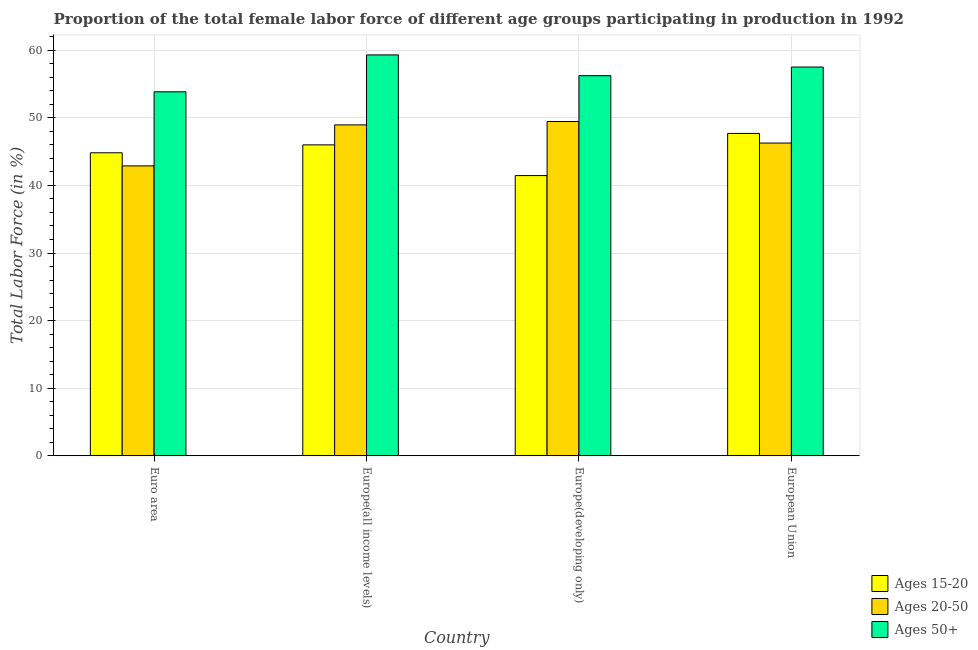How many different coloured bars are there?
Your response must be concise. 3. Are the number of bars per tick equal to the number of legend labels?
Offer a terse response. Yes. Are the number of bars on each tick of the X-axis equal?
Offer a very short reply. Yes. What is the label of the 3rd group of bars from the left?
Give a very brief answer. Europe(developing only). In how many cases, is the number of bars for a given country not equal to the number of legend labels?
Provide a succinct answer. 0. What is the percentage of female labor force within the age group 20-50 in Euro area?
Provide a short and direct response. 42.89. Across all countries, what is the maximum percentage of female labor force above age 50?
Provide a short and direct response. 59.32. Across all countries, what is the minimum percentage of female labor force within the age group 20-50?
Provide a short and direct response. 42.89. In which country was the percentage of female labor force within the age group 15-20 maximum?
Give a very brief answer. European Union. In which country was the percentage of female labor force within the age group 20-50 minimum?
Keep it short and to the point. Euro area. What is the total percentage of female labor force above age 50 in the graph?
Your response must be concise. 226.94. What is the difference between the percentage of female labor force within the age group 15-20 in Euro area and that in European Union?
Your answer should be very brief. -2.87. What is the difference between the percentage of female labor force within the age group 20-50 in Euro area and the percentage of female labor force above age 50 in Europe(all income levels)?
Keep it short and to the point. -16.42. What is the average percentage of female labor force within the age group 20-50 per country?
Your answer should be compact. 46.9. What is the difference between the percentage of female labor force above age 50 and percentage of female labor force within the age group 20-50 in Europe(all income levels)?
Your answer should be very brief. 10.35. In how many countries, is the percentage of female labor force above age 50 greater than 48 %?
Ensure brevity in your answer.  4. What is the ratio of the percentage of female labor force within the age group 15-20 in Europe(developing only) to that in European Union?
Ensure brevity in your answer.  0.87. Is the difference between the percentage of female labor force above age 50 in Europe(developing only) and European Union greater than the difference between the percentage of female labor force within the age group 20-50 in Europe(developing only) and European Union?
Provide a short and direct response. No. What is the difference between the highest and the second highest percentage of female labor force within the age group 20-50?
Make the answer very short. 0.5. What is the difference between the highest and the lowest percentage of female labor force within the age group 15-20?
Provide a succinct answer. 6.24. In how many countries, is the percentage of female labor force above age 50 greater than the average percentage of female labor force above age 50 taken over all countries?
Ensure brevity in your answer.  2. What does the 1st bar from the left in European Union represents?
Provide a succinct answer. Ages 15-20. What does the 2nd bar from the right in European Union represents?
Provide a short and direct response. Ages 20-50. Is it the case that in every country, the sum of the percentage of female labor force within the age group 15-20 and percentage of female labor force within the age group 20-50 is greater than the percentage of female labor force above age 50?
Your answer should be very brief. Yes. How many bars are there?
Your answer should be compact. 12. What is the difference between two consecutive major ticks on the Y-axis?
Your response must be concise. 10. Are the values on the major ticks of Y-axis written in scientific E-notation?
Your response must be concise. No. What is the title of the graph?
Give a very brief answer. Proportion of the total female labor force of different age groups participating in production in 1992. Does "Self-employed" appear as one of the legend labels in the graph?
Your answer should be compact. No. What is the label or title of the X-axis?
Provide a succinct answer. Country. What is the label or title of the Y-axis?
Provide a succinct answer. Total Labor Force (in %). What is the Total Labor Force (in %) of Ages 15-20 in Euro area?
Offer a very short reply. 44.83. What is the Total Labor Force (in %) of Ages 20-50 in Euro area?
Offer a terse response. 42.89. What is the Total Labor Force (in %) of Ages 50+ in Euro area?
Your answer should be very brief. 53.86. What is the Total Labor Force (in %) in Ages 15-20 in Europe(all income levels)?
Keep it short and to the point. 46. What is the Total Labor Force (in %) in Ages 20-50 in Europe(all income levels)?
Offer a very short reply. 48.96. What is the Total Labor Force (in %) in Ages 50+ in Europe(all income levels)?
Ensure brevity in your answer.  59.32. What is the Total Labor Force (in %) of Ages 15-20 in Europe(developing only)?
Provide a short and direct response. 41.46. What is the Total Labor Force (in %) in Ages 20-50 in Europe(developing only)?
Your response must be concise. 49.46. What is the Total Labor Force (in %) of Ages 50+ in Europe(developing only)?
Provide a succinct answer. 56.24. What is the Total Labor Force (in %) of Ages 15-20 in European Union?
Your response must be concise. 47.7. What is the Total Labor Force (in %) in Ages 20-50 in European Union?
Your answer should be compact. 46.27. What is the Total Labor Force (in %) in Ages 50+ in European Union?
Offer a very short reply. 57.52. Across all countries, what is the maximum Total Labor Force (in %) of Ages 15-20?
Give a very brief answer. 47.7. Across all countries, what is the maximum Total Labor Force (in %) of Ages 20-50?
Offer a very short reply. 49.46. Across all countries, what is the maximum Total Labor Force (in %) in Ages 50+?
Offer a terse response. 59.32. Across all countries, what is the minimum Total Labor Force (in %) in Ages 15-20?
Your answer should be very brief. 41.46. Across all countries, what is the minimum Total Labor Force (in %) of Ages 20-50?
Your response must be concise. 42.89. Across all countries, what is the minimum Total Labor Force (in %) in Ages 50+?
Offer a terse response. 53.86. What is the total Total Labor Force (in %) in Ages 15-20 in the graph?
Give a very brief answer. 179.99. What is the total Total Labor Force (in %) in Ages 20-50 in the graph?
Offer a terse response. 187.59. What is the total Total Labor Force (in %) in Ages 50+ in the graph?
Keep it short and to the point. 226.94. What is the difference between the Total Labor Force (in %) in Ages 15-20 in Euro area and that in Europe(all income levels)?
Provide a short and direct response. -1.17. What is the difference between the Total Labor Force (in %) of Ages 20-50 in Euro area and that in Europe(all income levels)?
Your answer should be very brief. -6.07. What is the difference between the Total Labor Force (in %) of Ages 50+ in Euro area and that in Europe(all income levels)?
Your answer should be very brief. -5.46. What is the difference between the Total Labor Force (in %) in Ages 15-20 in Euro area and that in Europe(developing only)?
Provide a short and direct response. 3.37. What is the difference between the Total Labor Force (in %) of Ages 20-50 in Euro area and that in Europe(developing only)?
Ensure brevity in your answer.  -6.57. What is the difference between the Total Labor Force (in %) of Ages 50+ in Euro area and that in Europe(developing only)?
Offer a terse response. -2.39. What is the difference between the Total Labor Force (in %) in Ages 15-20 in Euro area and that in European Union?
Give a very brief answer. -2.87. What is the difference between the Total Labor Force (in %) in Ages 20-50 in Euro area and that in European Union?
Keep it short and to the point. -3.38. What is the difference between the Total Labor Force (in %) in Ages 50+ in Euro area and that in European Union?
Offer a terse response. -3.67. What is the difference between the Total Labor Force (in %) of Ages 15-20 in Europe(all income levels) and that in Europe(developing only)?
Give a very brief answer. 4.55. What is the difference between the Total Labor Force (in %) of Ages 20-50 in Europe(all income levels) and that in Europe(developing only)?
Make the answer very short. -0.5. What is the difference between the Total Labor Force (in %) in Ages 50+ in Europe(all income levels) and that in Europe(developing only)?
Your response must be concise. 3.07. What is the difference between the Total Labor Force (in %) of Ages 15-20 in Europe(all income levels) and that in European Union?
Give a very brief answer. -1.69. What is the difference between the Total Labor Force (in %) in Ages 20-50 in Europe(all income levels) and that in European Union?
Offer a very short reply. 2.69. What is the difference between the Total Labor Force (in %) of Ages 50+ in Europe(all income levels) and that in European Union?
Keep it short and to the point. 1.79. What is the difference between the Total Labor Force (in %) of Ages 15-20 in Europe(developing only) and that in European Union?
Offer a very short reply. -6.24. What is the difference between the Total Labor Force (in %) of Ages 20-50 in Europe(developing only) and that in European Union?
Give a very brief answer. 3.19. What is the difference between the Total Labor Force (in %) in Ages 50+ in Europe(developing only) and that in European Union?
Keep it short and to the point. -1.28. What is the difference between the Total Labor Force (in %) of Ages 15-20 in Euro area and the Total Labor Force (in %) of Ages 20-50 in Europe(all income levels)?
Ensure brevity in your answer.  -4.13. What is the difference between the Total Labor Force (in %) of Ages 15-20 in Euro area and the Total Labor Force (in %) of Ages 50+ in Europe(all income levels)?
Your answer should be very brief. -14.48. What is the difference between the Total Labor Force (in %) in Ages 20-50 in Euro area and the Total Labor Force (in %) in Ages 50+ in Europe(all income levels)?
Offer a very short reply. -16.42. What is the difference between the Total Labor Force (in %) of Ages 15-20 in Euro area and the Total Labor Force (in %) of Ages 20-50 in Europe(developing only)?
Provide a short and direct response. -4.63. What is the difference between the Total Labor Force (in %) in Ages 15-20 in Euro area and the Total Labor Force (in %) in Ages 50+ in Europe(developing only)?
Give a very brief answer. -11.41. What is the difference between the Total Labor Force (in %) of Ages 20-50 in Euro area and the Total Labor Force (in %) of Ages 50+ in Europe(developing only)?
Keep it short and to the point. -13.35. What is the difference between the Total Labor Force (in %) in Ages 15-20 in Euro area and the Total Labor Force (in %) in Ages 20-50 in European Union?
Offer a very short reply. -1.44. What is the difference between the Total Labor Force (in %) of Ages 15-20 in Euro area and the Total Labor Force (in %) of Ages 50+ in European Union?
Ensure brevity in your answer.  -12.69. What is the difference between the Total Labor Force (in %) of Ages 20-50 in Euro area and the Total Labor Force (in %) of Ages 50+ in European Union?
Provide a short and direct response. -14.63. What is the difference between the Total Labor Force (in %) of Ages 15-20 in Europe(all income levels) and the Total Labor Force (in %) of Ages 20-50 in Europe(developing only)?
Provide a succinct answer. -3.46. What is the difference between the Total Labor Force (in %) of Ages 15-20 in Europe(all income levels) and the Total Labor Force (in %) of Ages 50+ in Europe(developing only)?
Your answer should be very brief. -10.24. What is the difference between the Total Labor Force (in %) of Ages 20-50 in Europe(all income levels) and the Total Labor Force (in %) of Ages 50+ in Europe(developing only)?
Your answer should be very brief. -7.28. What is the difference between the Total Labor Force (in %) of Ages 15-20 in Europe(all income levels) and the Total Labor Force (in %) of Ages 20-50 in European Union?
Keep it short and to the point. -0.27. What is the difference between the Total Labor Force (in %) of Ages 15-20 in Europe(all income levels) and the Total Labor Force (in %) of Ages 50+ in European Union?
Your answer should be very brief. -11.52. What is the difference between the Total Labor Force (in %) of Ages 20-50 in Europe(all income levels) and the Total Labor Force (in %) of Ages 50+ in European Union?
Provide a short and direct response. -8.56. What is the difference between the Total Labor Force (in %) in Ages 15-20 in Europe(developing only) and the Total Labor Force (in %) in Ages 20-50 in European Union?
Your answer should be compact. -4.81. What is the difference between the Total Labor Force (in %) in Ages 15-20 in Europe(developing only) and the Total Labor Force (in %) in Ages 50+ in European Union?
Your response must be concise. -16.06. What is the difference between the Total Labor Force (in %) in Ages 20-50 in Europe(developing only) and the Total Labor Force (in %) in Ages 50+ in European Union?
Ensure brevity in your answer.  -8.06. What is the average Total Labor Force (in %) of Ages 15-20 per country?
Your answer should be compact. 45. What is the average Total Labor Force (in %) in Ages 20-50 per country?
Your answer should be compact. 46.9. What is the average Total Labor Force (in %) in Ages 50+ per country?
Keep it short and to the point. 56.73. What is the difference between the Total Labor Force (in %) of Ages 15-20 and Total Labor Force (in %) of Ages 20-50 in Euro area?
Your answer should be very brief. 1.94. What is the difference between the Total Labor Force (in %) in Ages 15-20 and Total Labor Force (in %) in Ages 50+ in Euro area?
Make the answer very short. -9.03. What is the difference between the Total Labor Force (in %) of Ages 20-50 and Total Labor Force (in %) of Ages 50+ in Euro area?
Offer a terse response. -10.96. What is the difference between the Total Labor Force (in %) of Ages 15-20 and Total Labor Force (in %) of Ages 20-50 in Europe(all income levels)?
Make the answer very short. -2.96. What is the difference between the Total Labor Force (in %) of Ages 15-20 and Total Labor Force (in %) of Ages 50+ in Europe(all income levels)?
Provide a succinct answer. -13.31. What is the difference between the Total Labor Force (in %) of Ages 20-50 and Total Labor Force (in %) of Ages 50+ in Europe(all income levels)?
Provide a succinct answer. -10.35. What is the difference between the Total Labor Force (in %) in Ages 15-20 and Total Labor Force (in %) in Ages 20-50 in Europe(developing only)?
Offer a terse response. -8. What is the difference between the Total Labor Force (in %) in Ages 15-20 and Total Labor Force (in %) in Ages 50+ in Europe(developing only)?
Offer a very short reply. -14.79. What is the difference between the Total Labor Force (in %) in Ages 20-50 and Total Labor Force (in %) in Ages 50+ in Europe(developing only)?
Give a very brief answer. -6.78. What is the difference between the Total Labor Force (in %) in Ages 15-20 and Total Labor Force (in %) in Ages 20-50 in European Union?
Provide a succinct answer. 1.43. What is the difference between the Total Labor Force (in %) in Ages 15-20 and Total Labor Force (in %) in Ages 50+ in European Union?
Give a very brief answer. -9.83. What is the difference between the Total Labor Force (in %) of Ages 20-50 and Total Labor Force (in %) of Ages 50+ in European Union?
Offer a terse response. -11.25. What is the ratio of the Total Labor Force (in %) in Ages 15-20 in Euro area to that in Europe(all income levels)?
Give a very brief answer. 0.97. What is the ratio of the Total Labor Force (in %) in Ages 20-50 in Euro area to that in Europe(all income levels)?
Your response must be concise. 0.88. What is the ratio of the Total Labor Force (in %) of Ages 50+ in Euro area to that in Europe(all income levels)?
Your answer should be very brief. 0.91. What is the ratio of the Total Labor Force (in %) in Ages 15-20 in Euro area to that in Europe(developing only)?
Make the answer very short. 1.08. What is the ratio of the Total Labor Force (in %) of Ages 20-50 in Euro area to that in Europe(developing only)?
Provide a short and direct response. 0.87. What is the ratio of the Total Labor Force (in %) of Ages 50+ in Euro area to that in Europe(developing only)?
Ensure brevity in your answer.  0.96. What is the ratio of the Total Labor Force (in %) of Ages 15-20 in Euro area to that in European Union?
Your response must be concise. 0.94. What is the ratio of the Total Labor Force (in %) in Ages 20-50 in Euro area to that in European Union?
Ensure brevity in your answer.  0.93. What is the ratio of the Total Labor Force (in %) of Ages 50+ in Euro area to that in European Union?
Keep it short and to the point. 0.94. What is the ratio of the Total Labor Force (in %) in Ages 15-20 in Europe(all income levels) to that in Europe(developing only)?
Keep it short and to the point. 1.11. What is the ratio of the Total Labor Force (in %) of Ages 50+ in Europe(all income levels) to that in Europe(developing only)?
Your answer should be compact. 1.05. What is the ratio of the Total Labor Force (in %) in Ages 15-20 in Europe(all income levels) to that in European Union?
Keep it short and to the point. 0.96. What is the ratio of the Total Labor Force (in %) in Ages 20-50 in Europe(all income levels) to that in European Union?
Offer a terse response. 1.06. What is the ratio of the Total Labor Force (in %) of Ages 50+ in Europe(all income levels) to that in European Union?
Your response must be concise. 1.03. What is the ratio of the Total Labor Force (in %) in Ages 15-20 in Europe(developing only) to that in European Union?
Give a very brief answer. 0.87. What is the ratio of the Total Labor Force (in %) of Ages 20-50 in Europe(developing only) to that in European Union?
Ensure brevity in your answer.  1.07. What is the ratio of the Total Labor Force (in %) in Ages 50+ in Europe(developing only) to that in European Union?
Your response must be concise. 0.98. What is the difference between the highest and the second highest Total Labor Force (in %) in Ages 15-20?
Keep it short and to the point. 1.69. What is the difference between the highest and the second highest Total Labor Force (in %) in Ages 20-50?
Offer a terse response. 0.5. What is the difference between the highest and the second highest Total Labor Force (in %) of Ages 50+?
Your response must be concise. 1.79. What is the difference between the highest and the lowest Total Labor Force (in %) of Ages 15-20?
Offer a very short reply. 6.24. What is the difference between the highest and the lowest Total Labor Force (in %) of Ages 20-50?
Provide a succinct answer. 6.57. What is the difference between the highest and the lowest Total Labor Force (in %) in Ages 50+?
Offer a very short reply. 5.46. 